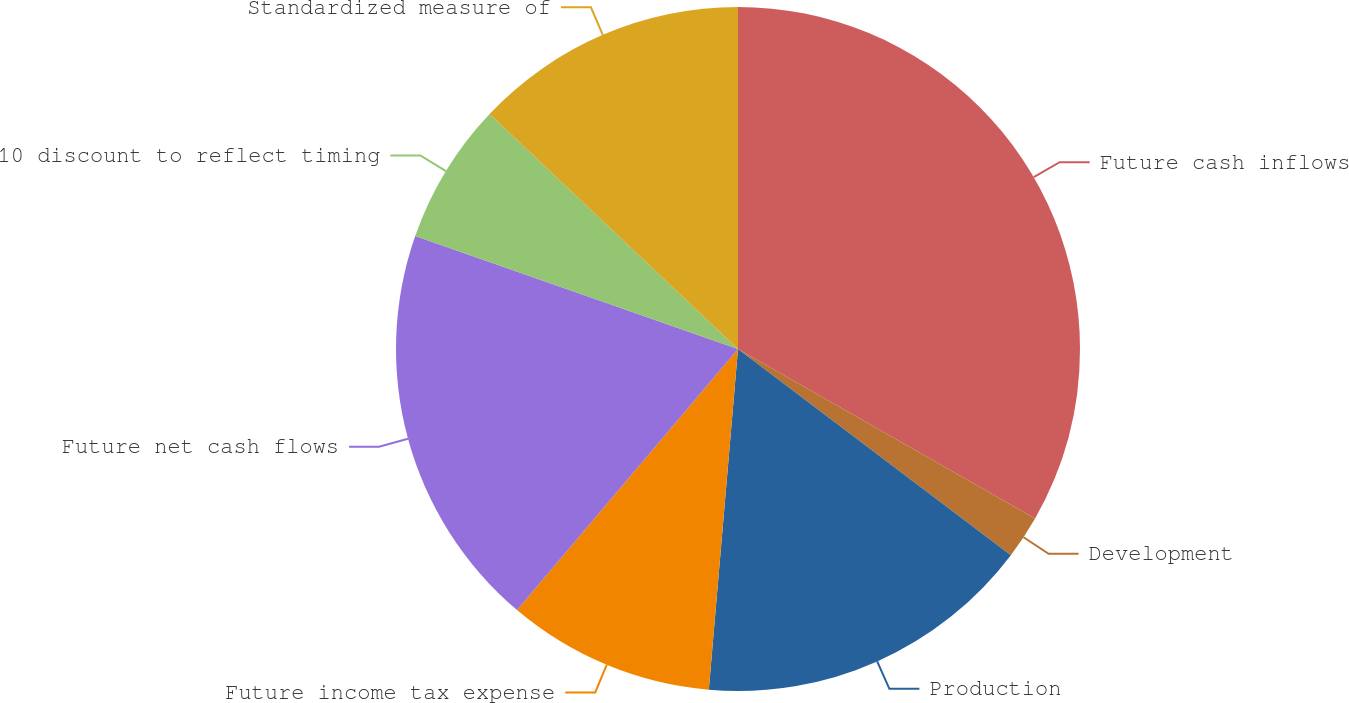Convert chart to OTSL. <chart><loc_0><loc_0><loc_500><loc_500><pie_chart><fcel>Future cash inflows<fcel>Development<fcel>Production<fcel>Future income tax expense<fcel>Future net cash flows<fcel>10 discount to reflect timing<fcel>Standardized measure of<nl><fcel>33.25%<fcel>2.05%<fcel>16.06%<fcel>9.82%<fcel>19.18%<fcel>6.7%<fcel>12.94%<nl></chart> 